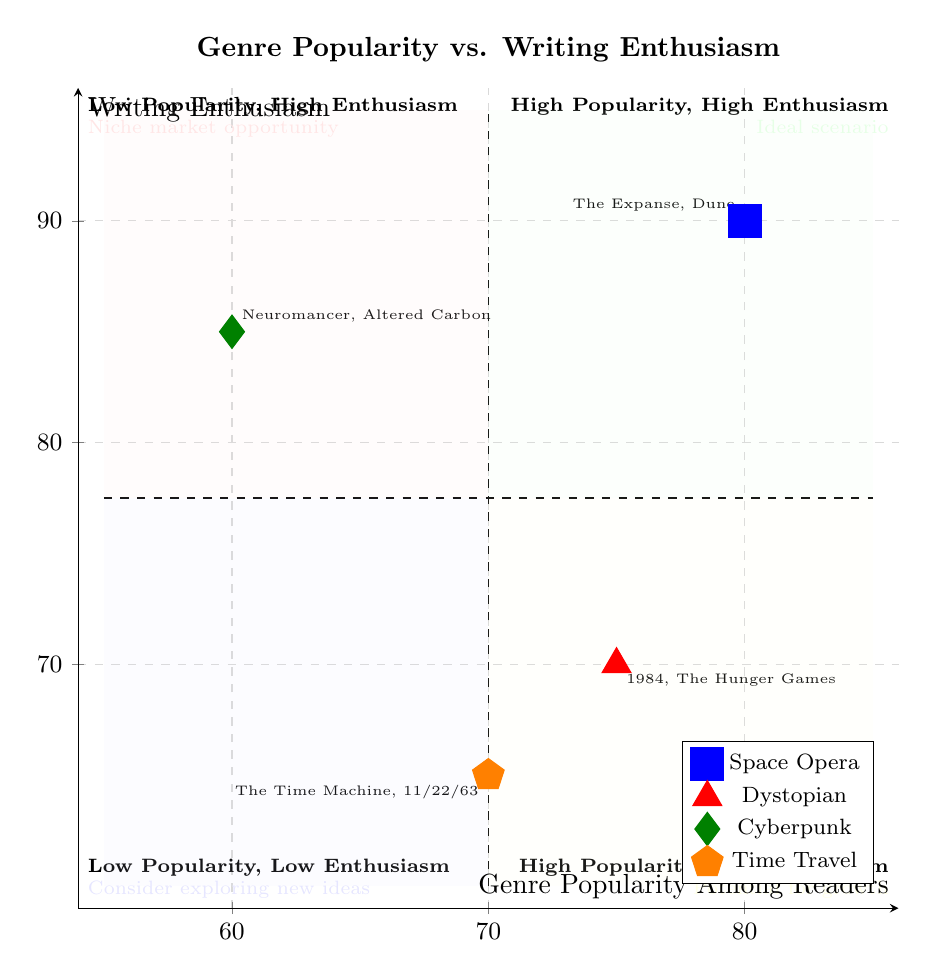What is the writing enthusiasm score for Space Opera? The writing enthusiasm score for Space Opera is located on the y-axis corresponding to its x-axis popularity score of 80. By examining the plot, I see that the point for Space Opera aligns with a y-value of 90.
Answer: 90 What genre has the lowest popularity score? By comparing the popularity scores of all the genres plotted along the x-axis, I observe that Time Travel has the lowest popularity score at 70.
Answer: Time Travel Which genre offers a niche market opportunity based on the quadrant sections? To identify the genre in the niche market opportunity section (Low Popularity, High Enthusiasm), I review the fourth quadrant. The only genre that fits this description is Cyberpunk, which has low popularity and high enthusiasm scores.
Answer: Cyberpunk What is the popularity score of Cyberpunk? The popularity score for Cyberpunk can be read directly from the x-coordinate related to its position on the graph, which is 60.
Answer: 60 How many genres fall into the Ideal scenario quadrant? To find the number of genres in the Ideal scenario quadrant (High Popularity, High Enthusiasm), I look for the point that is in this quadrant. Only Space Opera is in this quadrant, so there is one genre.
Answer: 1 What is the relationship between Dystopian's popularity and enthusiasm scores? I compare the scores directly; Dystopian has a popularity score of 75 and an enthusiasm score of 70. This analysis shows that the enthusiasm is lower than the popularity in this case.
Answer: Lower Which genre has the highest writing enthusiasm score? I examine the y-values of all genres plotted on the diagram. The highest writing enthusiasm score is for Space Opera at 90.
Answer: Space Opera How many genres have high enthusiasm (greater than 80)? I analyze the enthusiasm scores for each genre. Space Opera (90) and Cyberpunk (85) have enthusiasm scores greater than 80, totaling two genres.
Answer: 2 What is shared by the genres located in the Low Popularity, Low Enthusiasm quadrant? The genres in the Low Popularity, Low Enthusiasm quadrant do not have high reader interest or the authors' enthusiasm. Based on the plotted data, Time Travel is the only genre in this quadrant.
Answer: Time Travel 